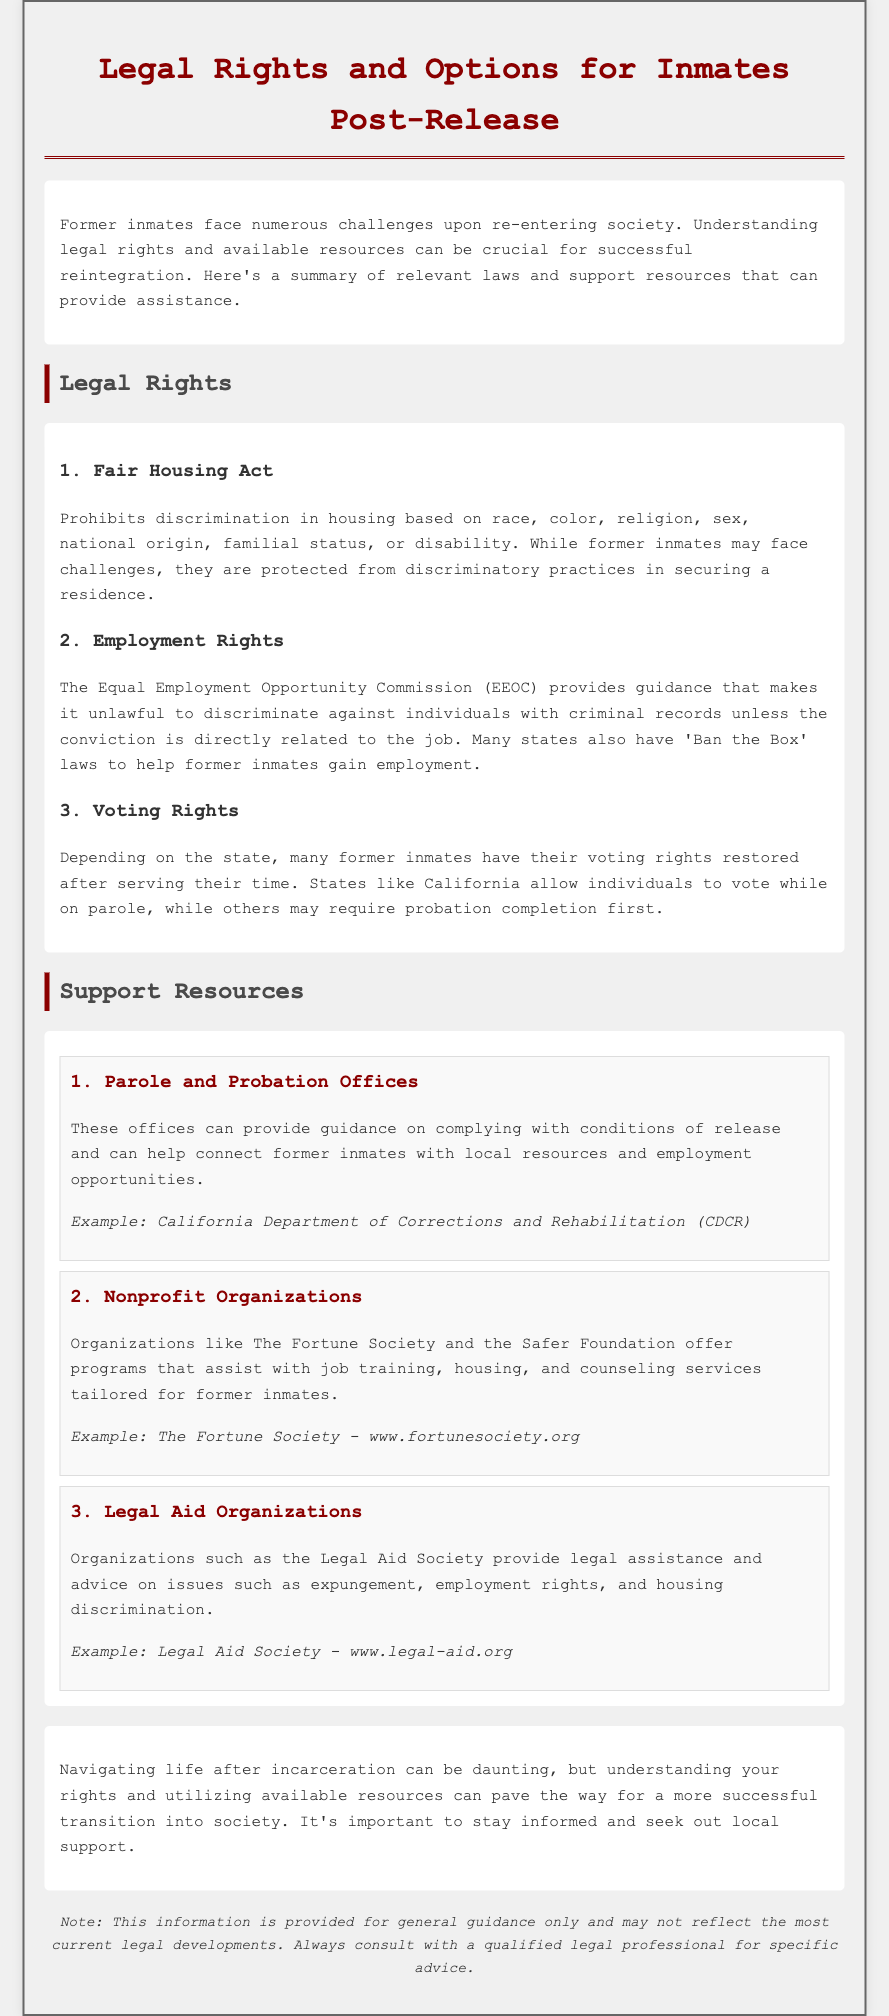What does the Fair Housing Act prohibit? The Fair Housing Act prohibits discrimination in housing based on several factors.
Answer: Discrimination in housing What organization provides guidance on employment rights? The document mentions an organization that addresses unfair employment practices.
Answer: Equal Employment Opportunity Commission (EEOC) Which state allows individuals to vote while on parole? The document specifies a state practice regarding voting rights post-release.
Answer: California Name one nonprofit organization supporting former inmates. The document lists organizations that offer assistance to former inmates.
Answer: The Fortune Society What type of legal assistance do Legal Aid Organizations provide? The document describes the services offered by legal aid organizations for various issues.
Answer: Legal assistance and advice How many main sections are in the document? The document is divided into multiple sections detailing different topics related to re-entry.
Answer: 3 What is the main purpose of this document? The document aims to outline the legal rights and resources available to former inmates.
Answer: Outline legal rights and resources Which resource helps with compliance on conditions of release? The document identifies a source that assists with understanding release conditions.
Answer: Parole and Probation Offices 